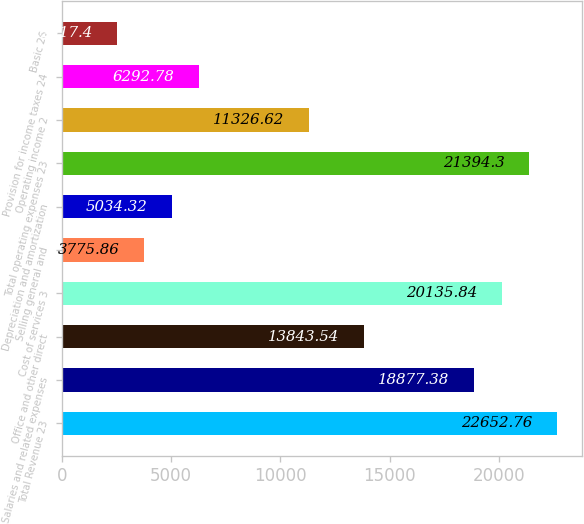Convert chart. <chart><loc_0><loc_0><loc_500><loc_500><bar_chart><fcel>Total Revenue 23<fcel>Salaries and related expenses<fcel>Office and other direct<fcel>Cost of services 3<fcel>Selling general and<fcel>Depreciation and amortization<fcel>Total operating expenses 23<fcel>Operating income 2<fcel>Provision for income taxes 24<fcel>Basic 26<nl><fcel>22652.8<fcel>18877.4<fcel>13843.5<fcel>20135.8<fcel>3775.86<fcel>5034.32<fcel>21394.3<fcel>11326.6<fcel>6292.78<fcel>2517.4<nl></chart> 